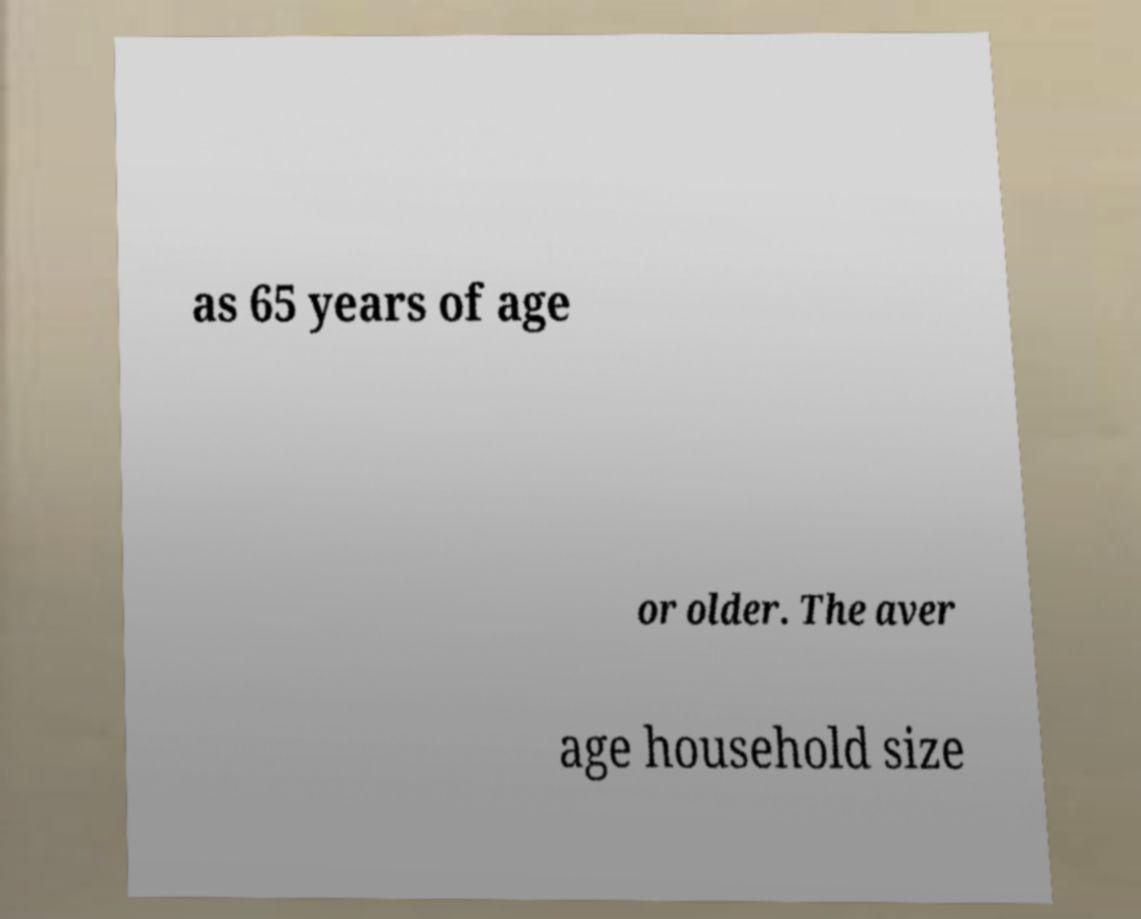What messages or text are displayed in this image? I need them in a readable, typed format. as 65 years of age or older. The aver age household size 